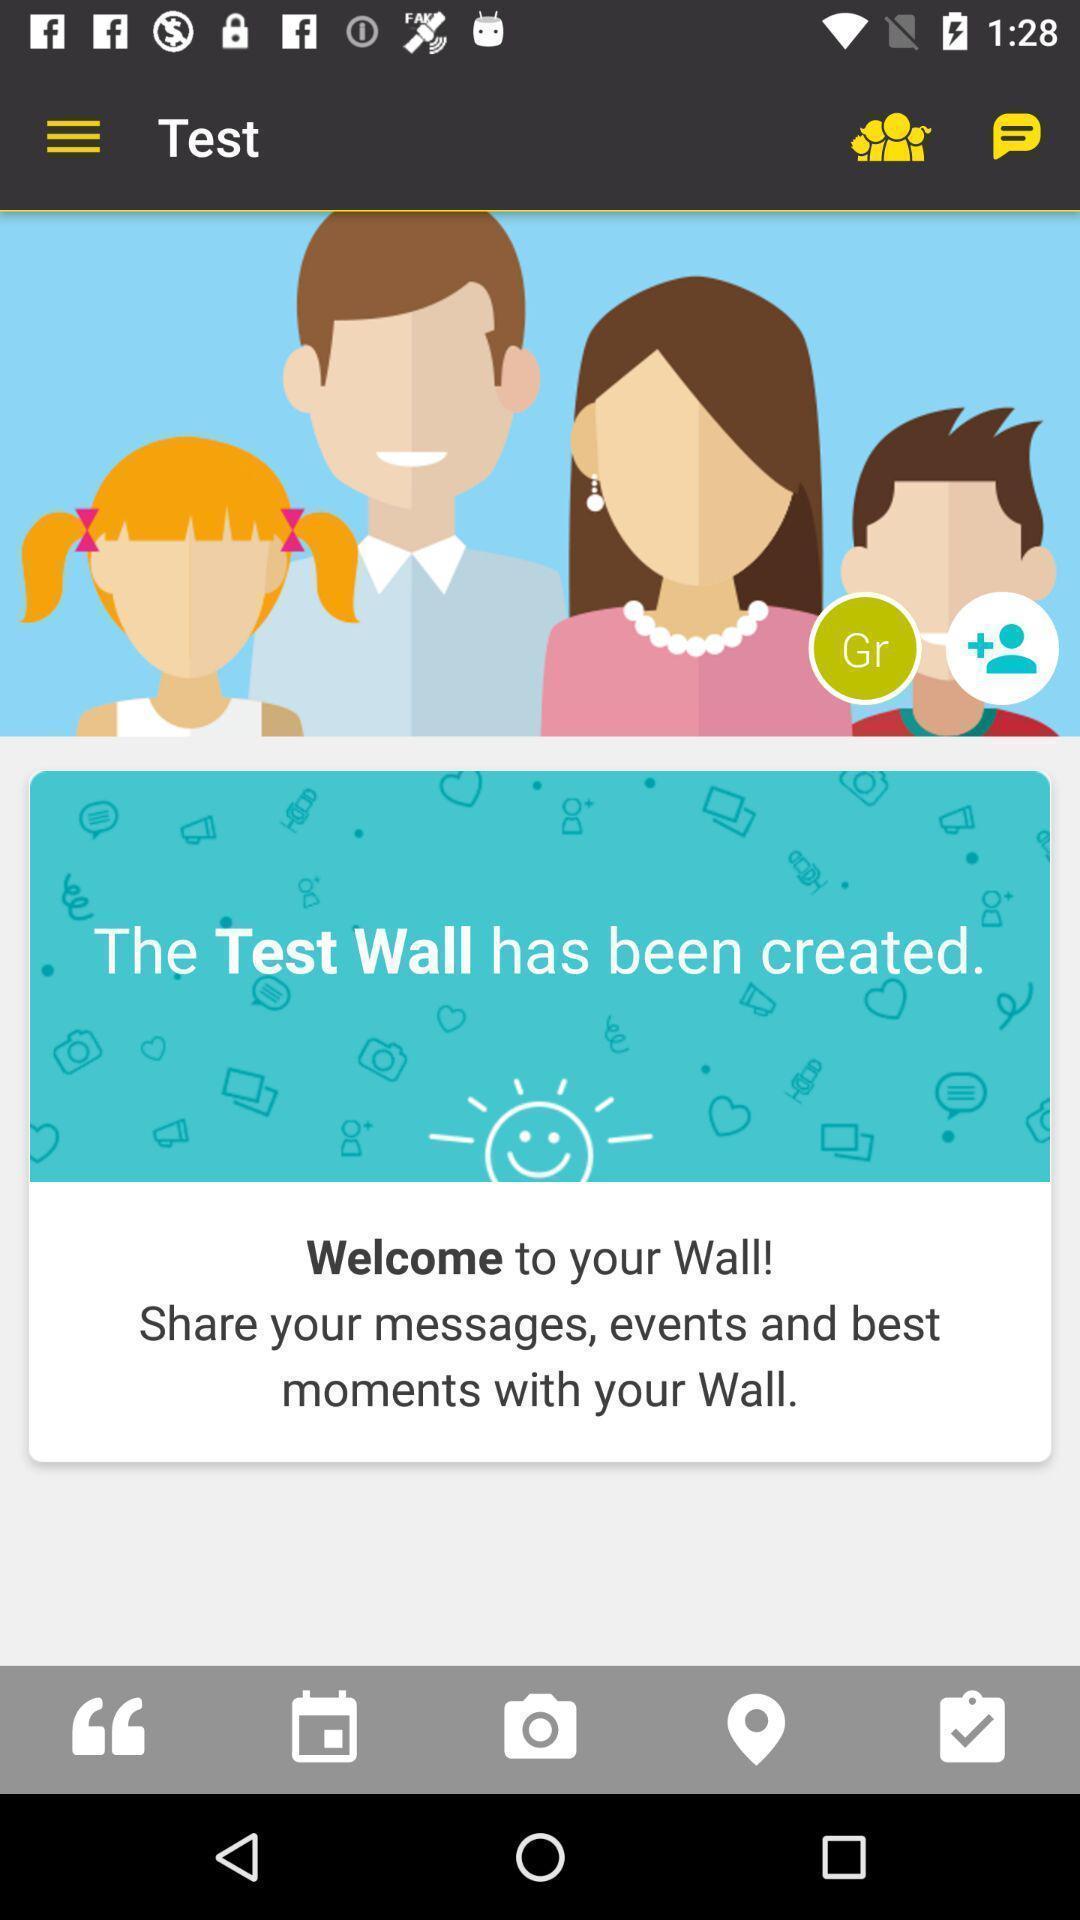Provide a textual representation of this image. Welcome page. 